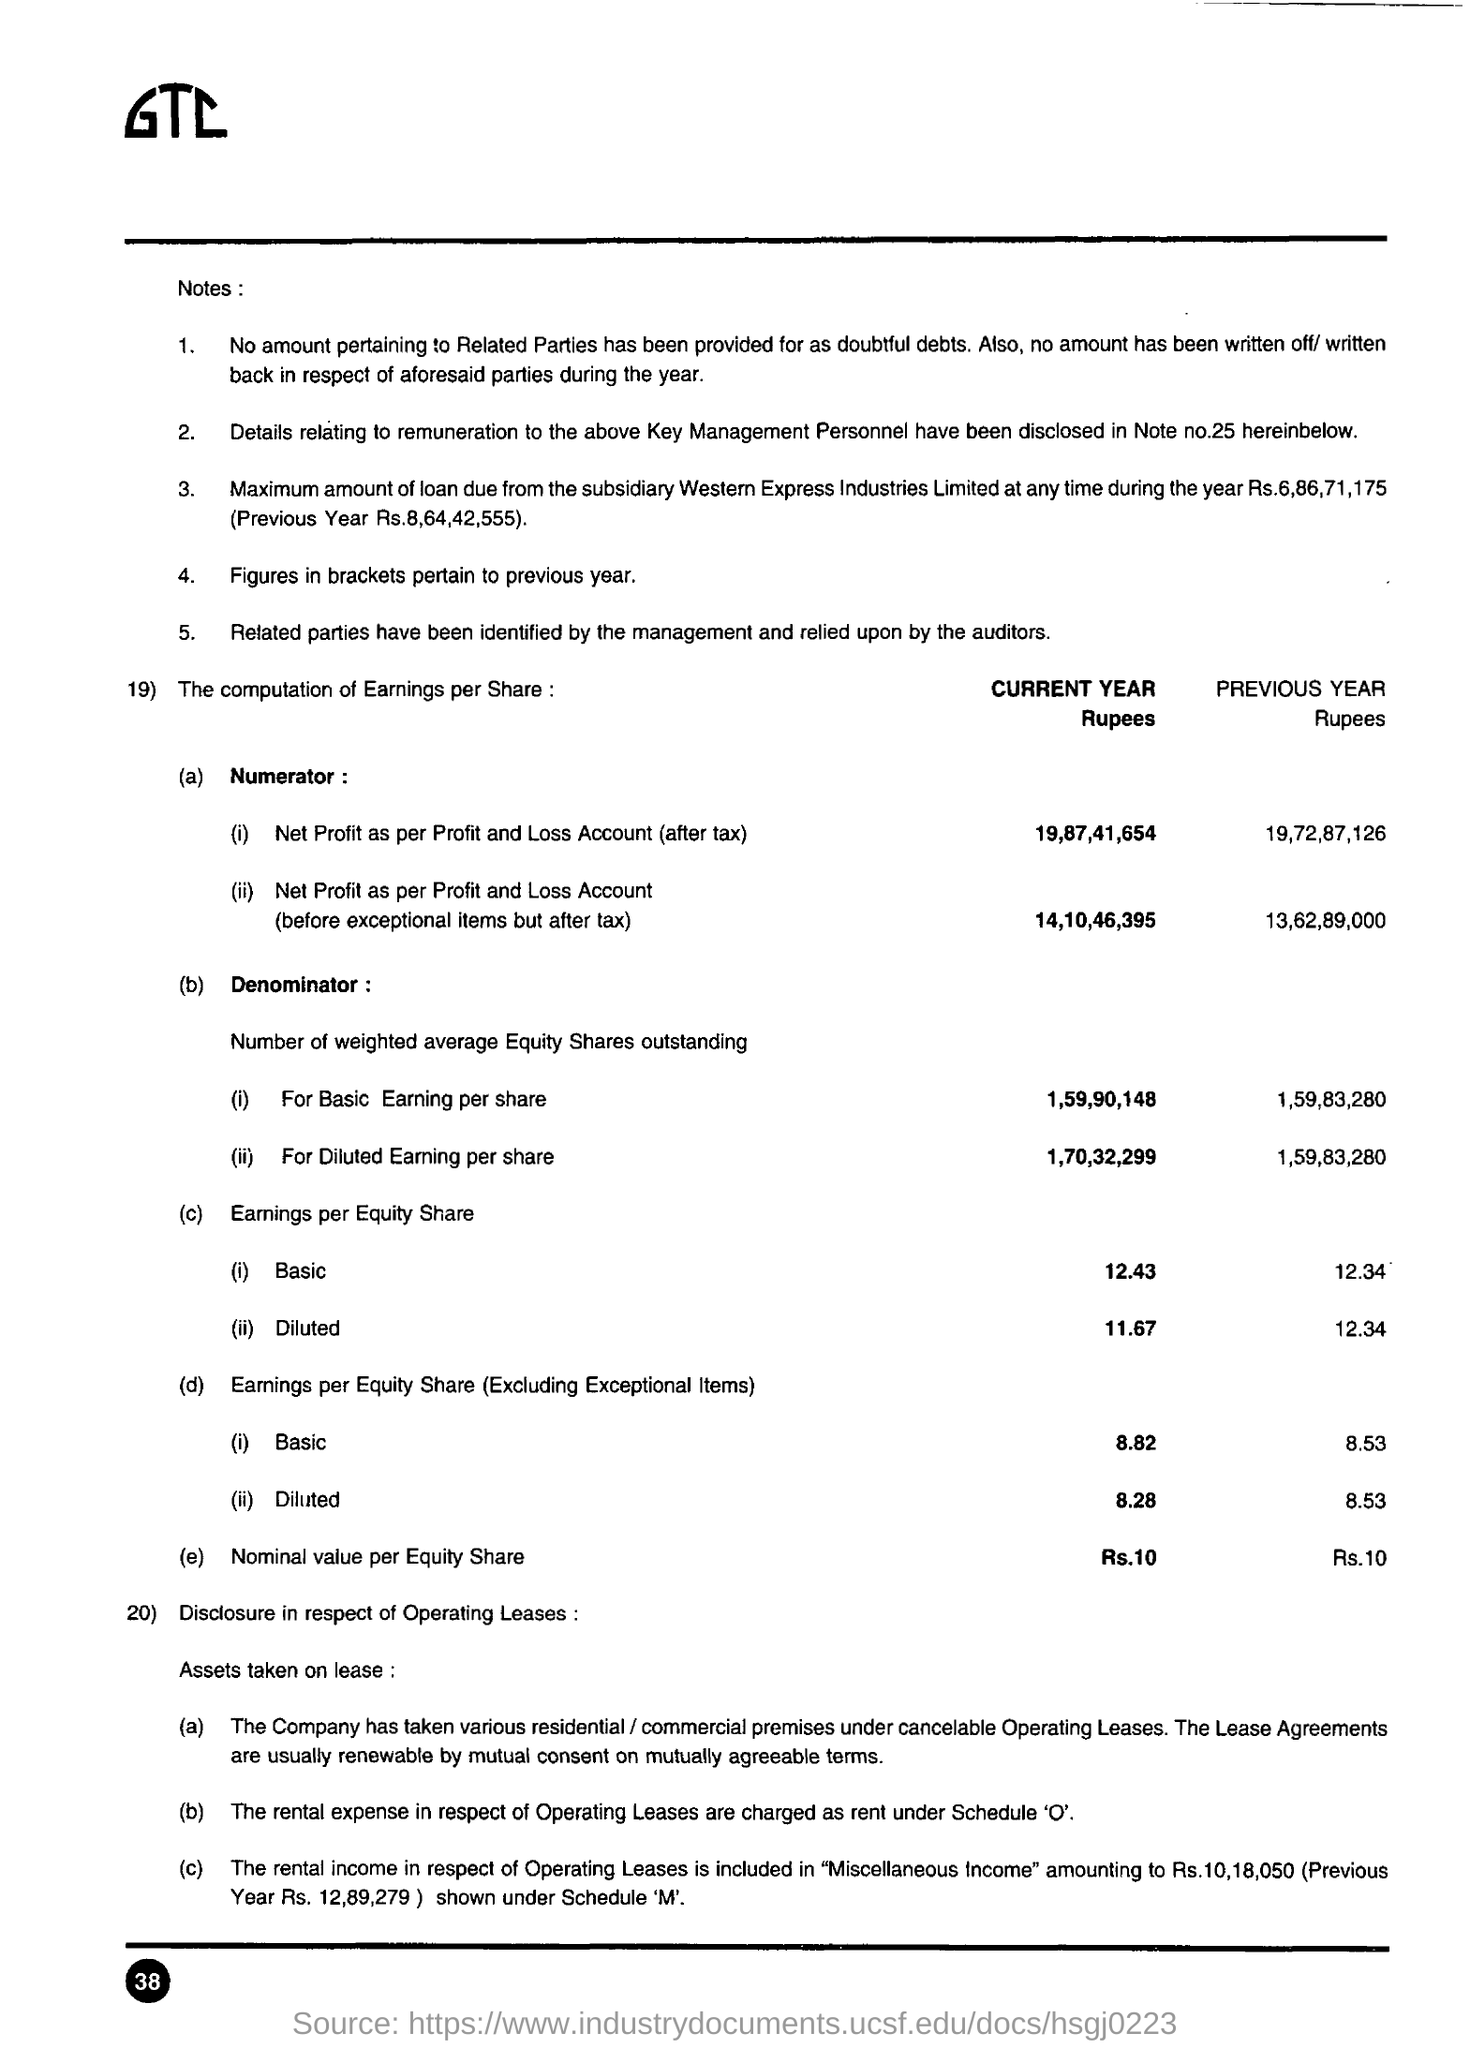Identify some key points in this picture. The nominal value per equity share for the current year is Rs. 10. The rental income in respect of operating leases is included in miscellaneous income. The net profit after tax for the current year, as per the profit and loss account, is 19,87,41,654. The maximum loan amount due from the subsidiary Western Express Industries Limited for the previous year was Rs.8,64,42,555. The figures in parentheses pertain to the previous year. 